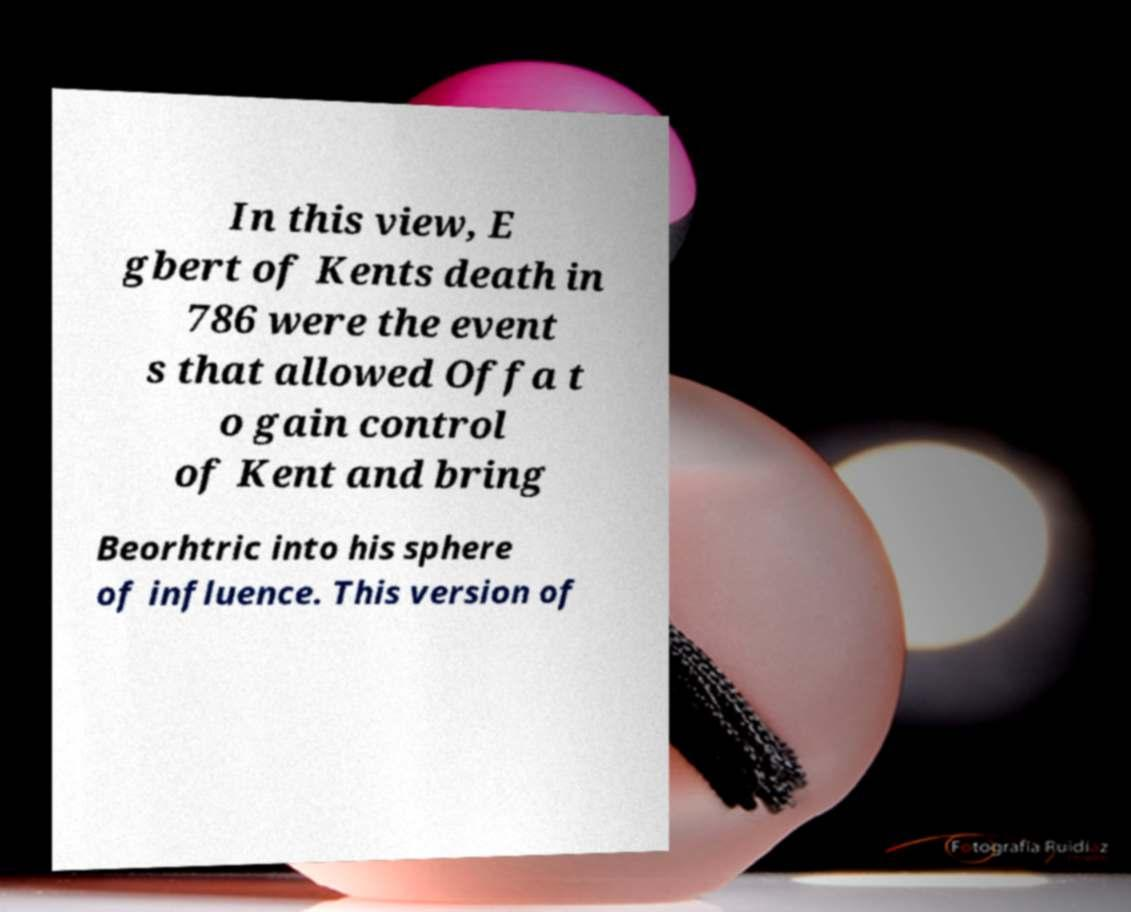Please identify and transcribe the text found in this image. In this view, E gbert of Kents death in 786 were the event s that allowed Offa t o gain control of Kent and bring Beorhtric into his sphere of influence. This version of 